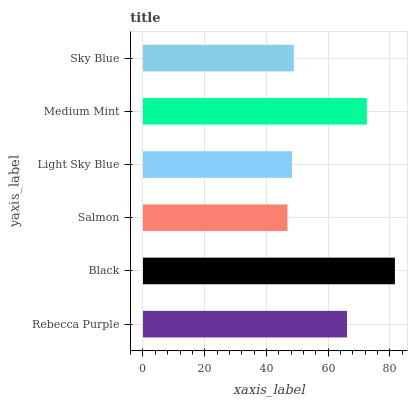Is Salmon the minimum?
Answer yes or no. Yes. Is Black the maximum?
Answer yes or no. Yes. Is Black the minimum?
Answer yes or no. No. Is Salmon the maximum?
Answer yes or no. No. Is Black greater than Salmon?
Answer yes or no. Yes. Is Salmon less than Black?
Answer yes or no. Yes. Is Salmon greater than Black?
Answer yes or no. No. Is Black less than Salmon?
Answer yes or no. No. Is Rebecca Purple the high median?
Answer yes or no. Yes. Is Sky Blue the low median?
Answer yes or no. Yes. Is Black the high median?
Answer yes or no. No. Is Rebecca Purple the low median?
Answer yes or no. No. 